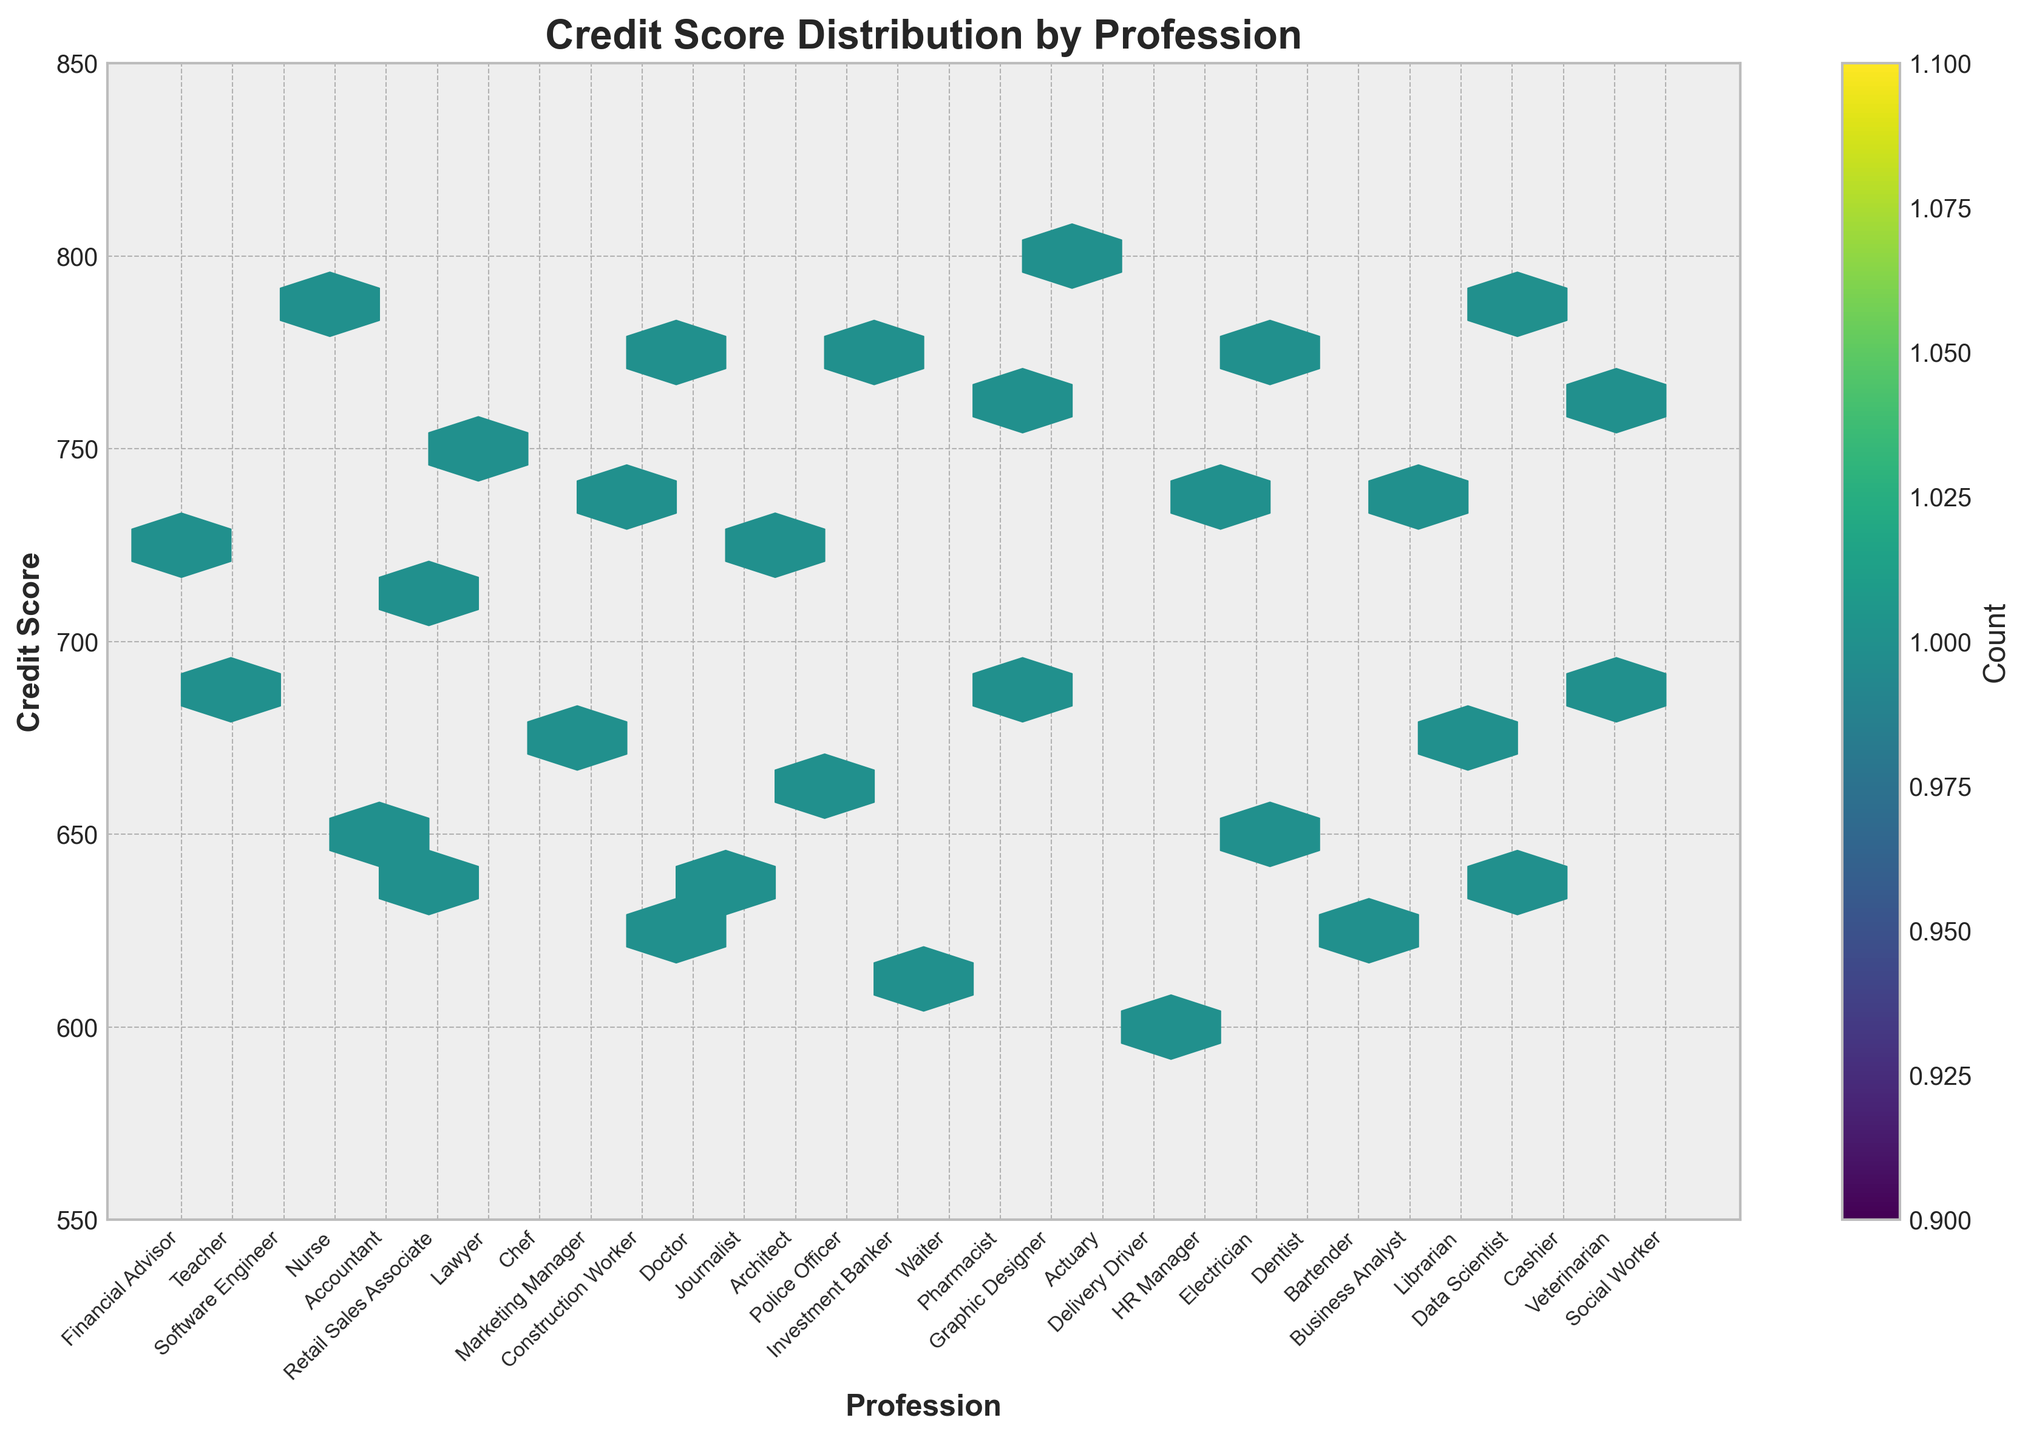What is the title of the plot? The title is displayed at the top of the plot. It says "Credit Score Distribution by Profession," which indicates the focus of the plot.
Answer: Credit Score Distribution by Profession Which profession has the highest credit score in the plot? The hexbin plot shows individual hexagons representing credit scores for each profession. The data confirms that the profession with the highest credit score is "Actuary."
Answer: Actuary Which profession has the lowest credit score in the plot? Observing the plot, the hexagon positioned lowest on the y-axis under the “Profession” label corresponds to "Delivery Driver," indicating the lowest credit score.
Answer: Delivery Driver What is the color scheme of the hexbin plot? The hexbin plot uses a colormap to represent density. In this plot, ranges from lighter shades to darker ones in the 'viridis' color spectrum indicate the density of points.
Answer: Viridis color spectrum What is the profession with the maximum density of credit scores? Examining the plot's color density and looking at the colorbar indicating the count, the profession “Financial Advisor” shows the highest density in the brighter-colored hexagons, representing the maximum count of credit scores.
Answer: Financial Advisor How many professions are represented in the plot? The x-axis ticks show labels for each profession. Counting them reveals that there are 30 unique professions visualized in the plot.
Answer: 30 Which range of credit scores is most common for the profession “Healthcare”? Identifying the relative position of the Healthcare professions like Nurse, Doctor, Pharmacist, and Veterinarian in the plot and their hexagons, it appears their credit scores mostly cluster around 750-770.
Answer: 750-770 What is the average credit score for Finance professions in the plot? Professions in Finance include Financial Advisor, Accountant, Investment Banker, and Business Analyst. Identifying their scores: 720, 710, 770, and 745. Calculating the average: (720 + 710 + 770 + 745) / 4 = 2365 / 4, which is approximately 741.25.
Answer: 741.25 Which two professions have the closest average credit scores? Calculate the average for each and compare: (Software Engineer 790, Data Scientist 785), calculate: (790 + 785) / 2 = 1575 / 2, which is 787.5. Comparison of averages shows these two professions have closely matched scores.
Answer: Software Engineer and Data Scientist Is there a profession in the "Technology" industry with a credit score below 780? Observing the plot and identifying technology-related professions like Software Engineer and Data Scientist, both exceed 780, indicating no profession in this industry is below 780 based on the plot.
Answer: No 